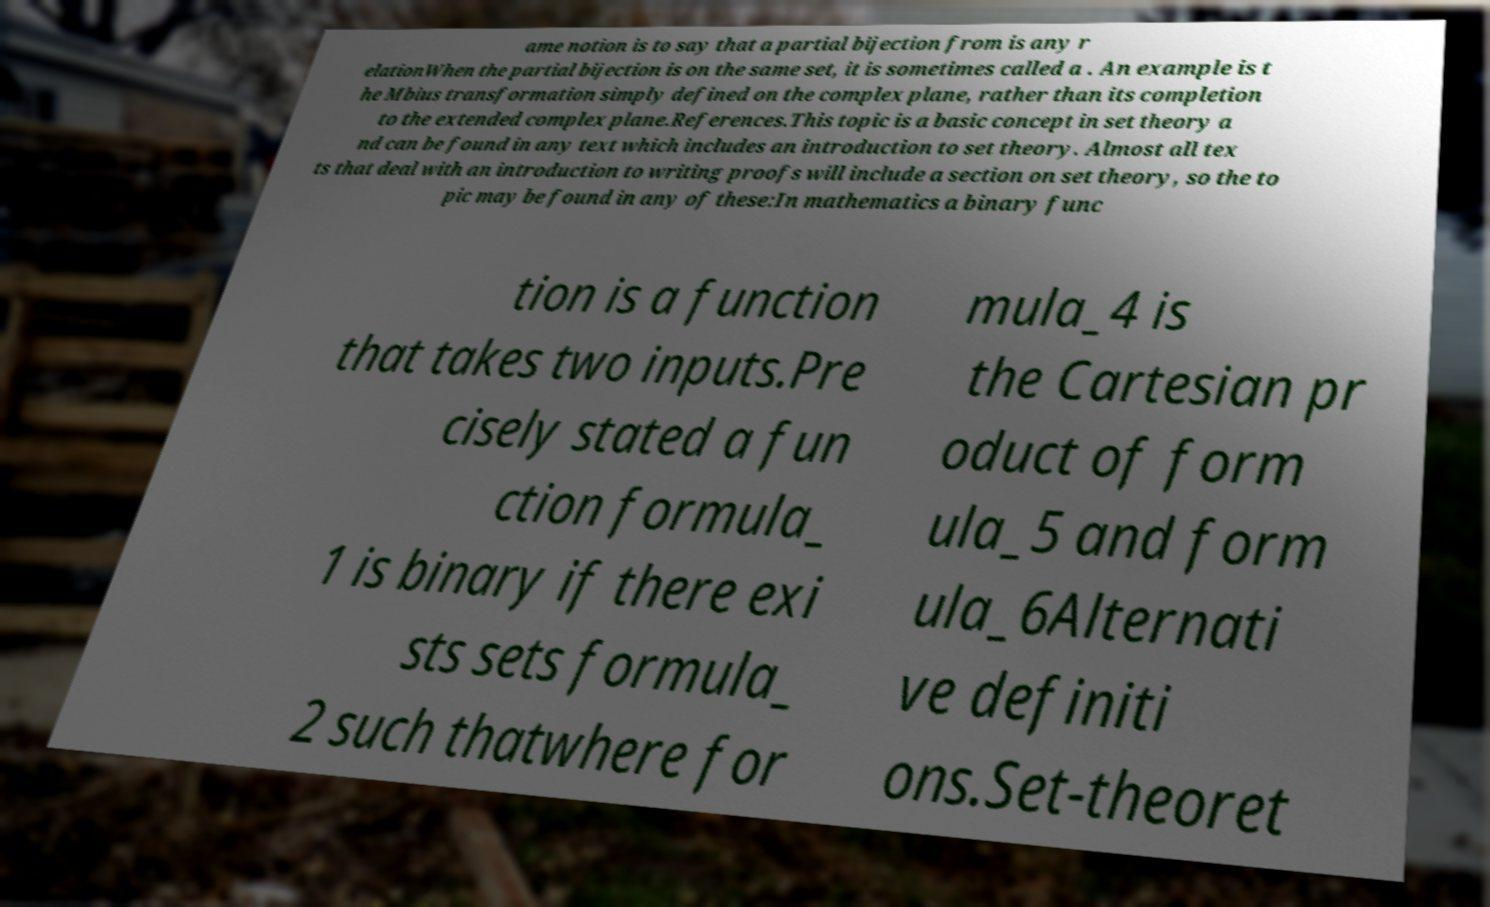For documentation purposes, I need the text within this image transcribed. Could you provide that? ame notion is to say that a partial bijection from is any r elationWhen the partial bijection is on the same set, it is sometimes called a . An example is t he Mbius transformation simply defined on the complex plane, rather than its completion to the extended complex plane.References.This topic is a basic concept in set theory a nd can be found in any text which includes an introduction to set theory. Almost all tex ts that deal with an introduction to writing proofs will include a section on set theory, so the to pic may be found in any of these:In mathematics a binary func tion is a function that takes two inputs.Pre cisely stated a fun ction formula_ 1 is binary if there exi sts sets formula_ 2 such thatwhere for mula_4 is the Cartesian pr oduct of form ula_5 and form ula_6Alternati ve definiti ons.Set-theoret 